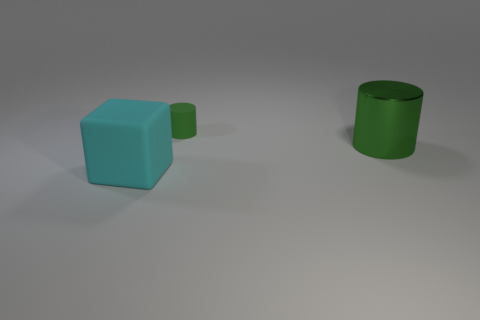Is there a green rubber cylinder that is behind the large object that is behind the big cyan matte thing that is on the left side of the small green cylinder? Yes, there is a green rubber cylinder positioned behind the large cyan block, which in turn is located behind the smaller green cylinder seen on the left. 